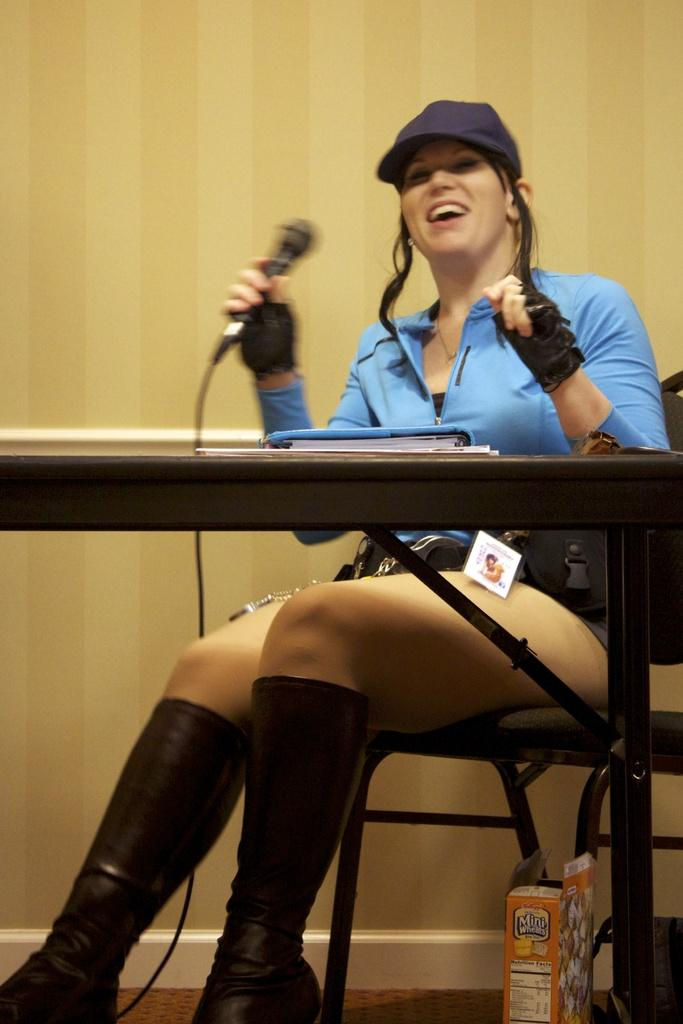Who is the main subject in the image? There is a woman in the image. What is the woman doing in the image? The woman is sitting on a chair and holding a microphone. What is the woman positioned in front of? The woman is in front of a table. What can be seen in the background of the image? There is a wall and a box in the background of the image. What is the price of the box in the image? There is no price mentioned or visible in the image, and therefore it cannot be determined. 